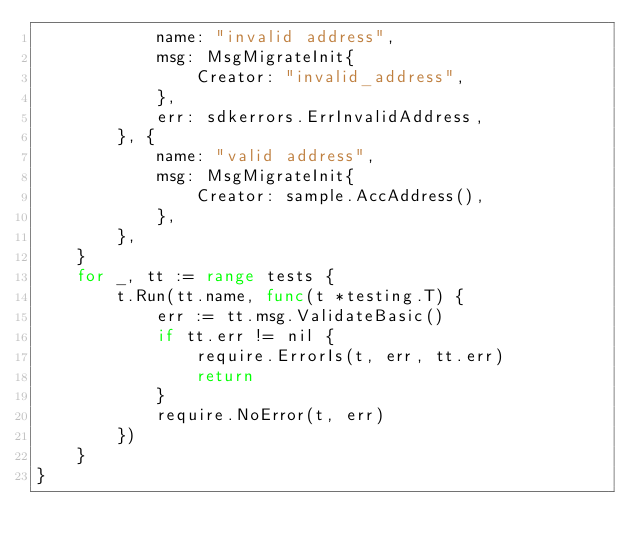Convert code to text. <code><loc_0><loc_0><loc_500><loc_500><_Go_>			name: "invalid address",
			msg: MsgMigrateInit{
				Creator: "invalid_address",
			},
			err: sdkerrors.ErrInvalidAddress,
		}, {
			name: "valid address",
			msg: MsgMigrateInit{
				Creator: sample.AccAddress(),
			},
		},
	}
	for _, tt := range tests {
		t.Run(tt.name, func(t *testing.T) {
			err := tt.msg.ValidateBasic()
			if tt.err != nil {
				require.ErrorIs(t, err, tt.err)
				return
			}
			require.NoError(t, err)
		})
	}
}
</code> 